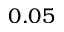Convert formula to latex. <formula><loc_0><loc_0><loc_500><loc_500>0 . 0 5</formula> 